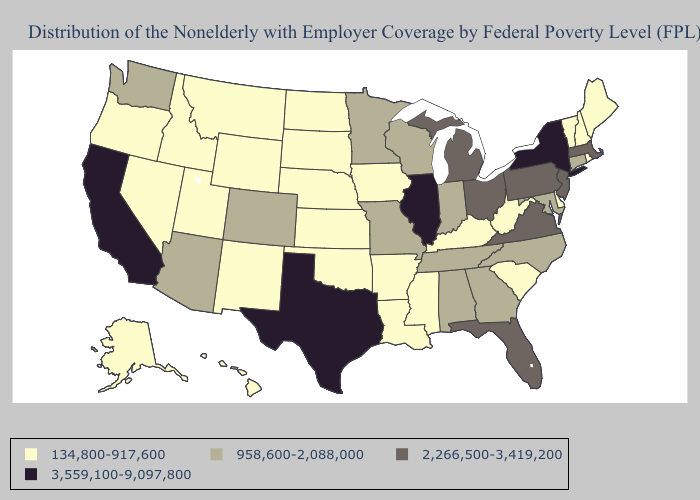Among the states that border South Dakota , does Wyoming have the lowest value?
Answer briefly. Yes. Does Ohio have the highest value in the MidWest?
Keep it brief. No. Which states hav the highest value in the MidWest?
Concise answer only. Illinois. Does Tennessee have the lowest value in the USA?
Answer briefly. No. Among the states that border Tennessee , which have the highest value?
Concise answer only. Virginia. Does Wyoming have a lower value than Colorado?
Concise answer only. Yes. What is the lowest value in the USA?
Write a very short answer. 134,800-917,600. What is the value of Delaware?
Answer briefly. 134,800-917,600. Name the states that have a value in the range 2,266,500-3,419,200?
Quick response, please. Florida, Massachusetts, Michigan, New Jersey, Ohio, Pennsylvania, Virginia. Is the legend a continuous bar?
Short answer required. No. Which states have the lowest value in the Northeast?
Answer briefly. Maine, New Hampshire, Rhode Island, Vermont. Does the first symbol in the legend represent the smallest category?
Keep it brief. Yes. Does the first symbol in the legend represent the smallest category?
Give a very brief answer. Yes. Which states have the lowest value in the USA?
Quick response, please. Alaska, Arkansas, Delaware, Hawaii, Idaho, Iowa, Kansas, Kentucky, Louisiana, Maine, Mississippi, Montana, Nebraska, Nevada, New Hampshire, New Mexico, North Dakota, Oklahoma, Oregon, Rhode Island, South Carolina, South Dakota, Utah, Vermont, West Virginia, Wyoming. Which states hav the highest value in the MidWest?
Keep it brief. Illinois. 